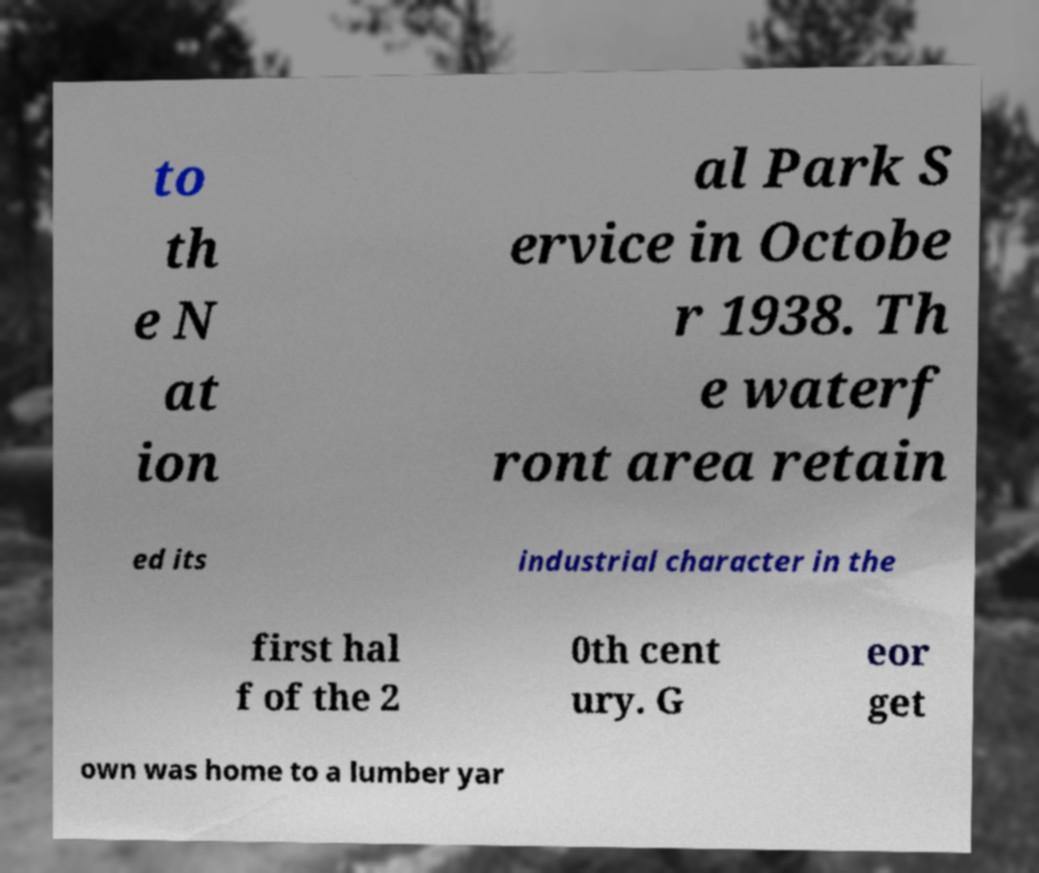I need the written content from this picture converted into text. Can you do that? to th e N at ion al Park S ervice in Octobe r 1938. Th e waterf ront area retain ed its industrial character in the first hal f of the 2 0th cent ury. G eor get own was home to a lumber yar 